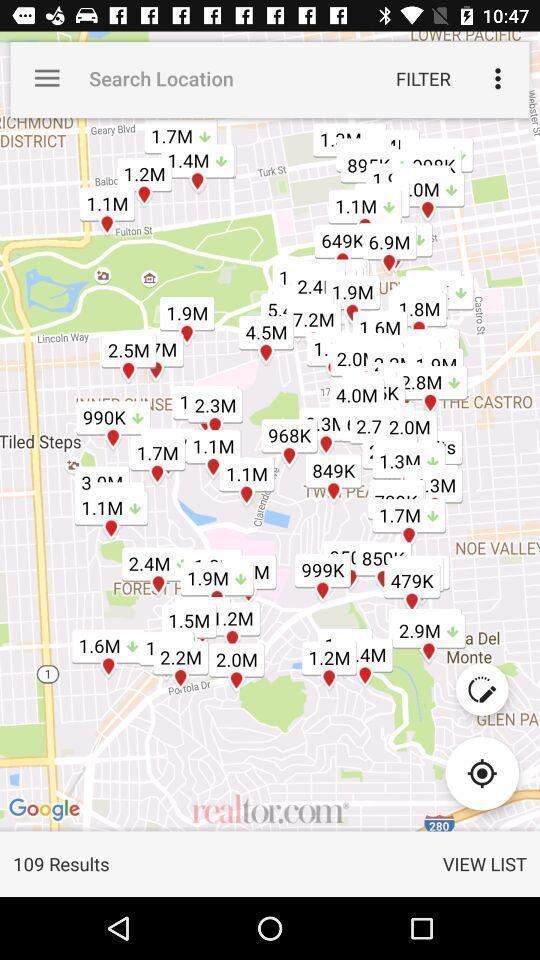Describe the key features of this screenshot. Search page for searching a location on map. 